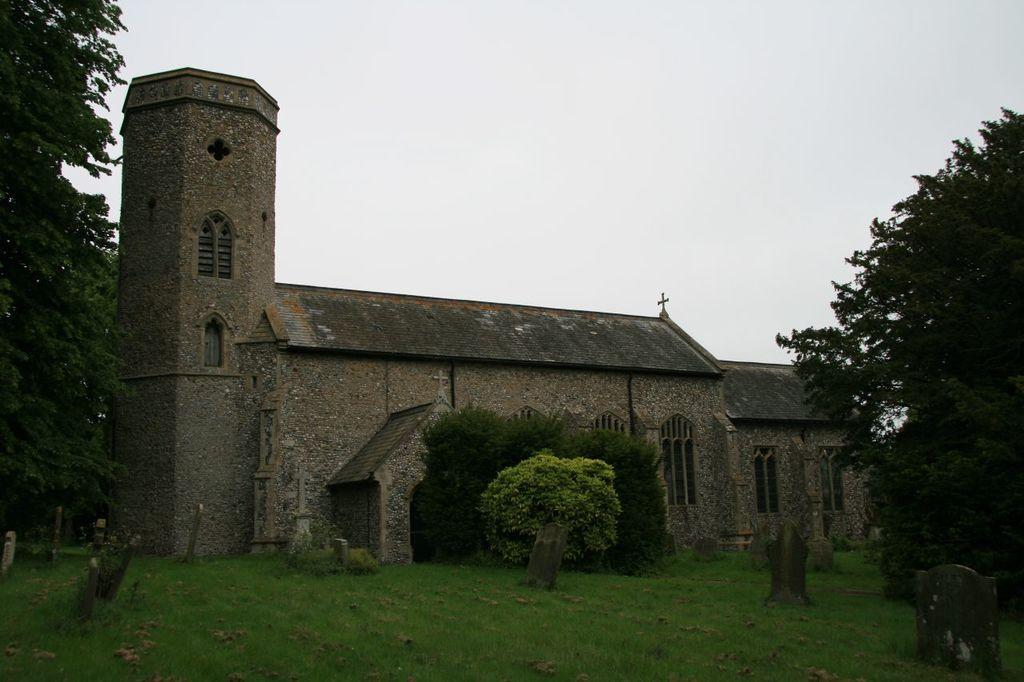What type of building is in the image? There is a church in the image. What type of vegetation is present in the image? There are trees and grass in the image. What type of structure can be found near the church? There are graveyard stones in the image. What is visible at the top of the image? The sky is visible at the top of the image. What type of key is used to unlock the church doors in the image? There is no key present in the image, and the church doors are not shown as being locked or unlocked. 